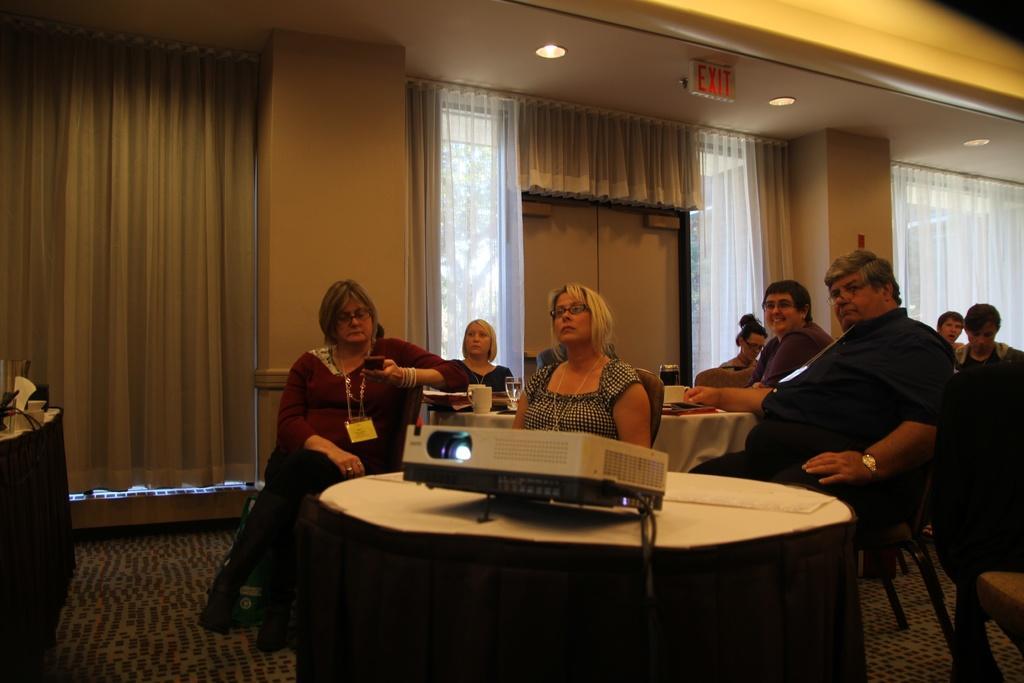Could you give a brief overview of what you see in this image? There is a projector on the table. There are some people sitting in chairs at tables behind it. There is a door with some glass frame and curtains in the back ground. There is a series of lights on the top. 